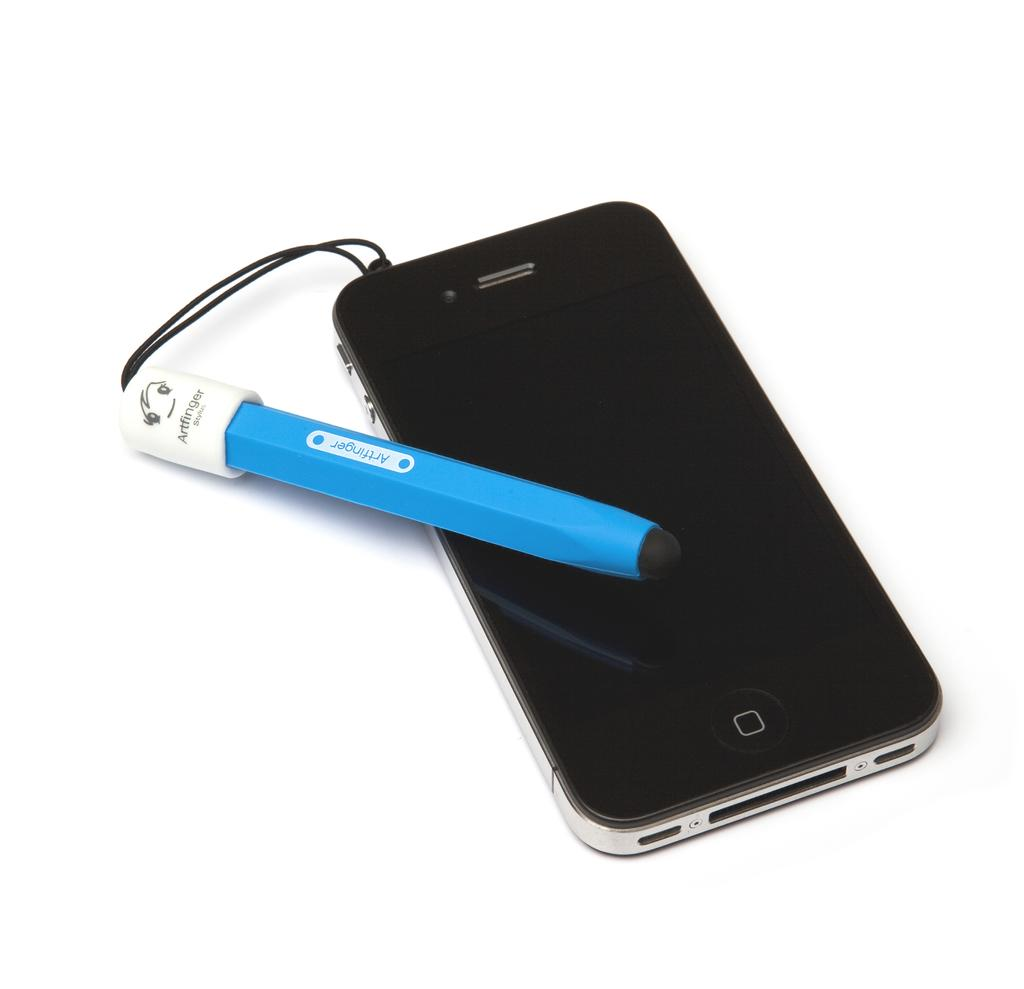<image>
Relay a brief, clear account of the picture shown. An apple branded iphone with an artfinger blue attachment hangin off of it. 